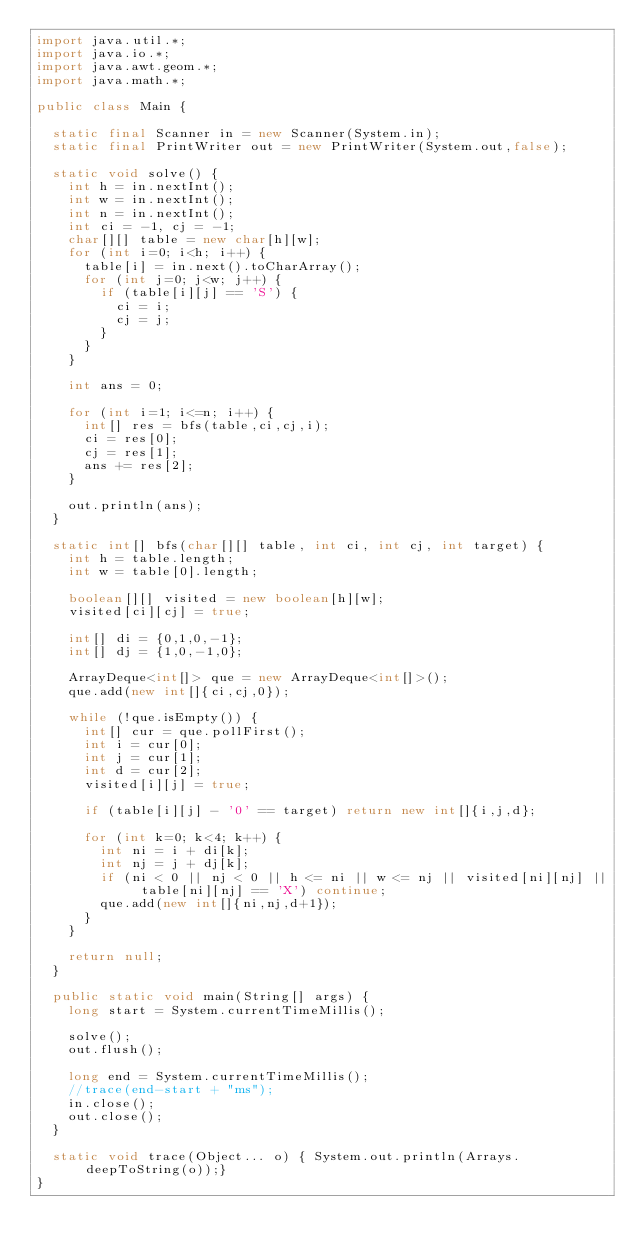Convert code to text. <code><loc_0><loc_0><loc_500><loc_500><_Java_>import java.util.*;
import java.io.*;
import java.awt.geom.*;
import java.math.*;

public class Main {

	static final Scanner in = new Scanner(System.in);
	static final PrintWriter out = new PrintWriter(System.out,false);

	static void solve() {
		int h = in.nextInt();
		int w = in.nextInt();
		int n = in.nextInt();
		int ci = -1, cj = -1;
		char[][] table = new char[h][w];
		for (int i=0; i<h; i++) {
			table[i] = in.next().toCharArray();
			for (int j=0; j<w; j++) {
				if (table[i][j] == 'S') {
					ci = i;
					cj = j;
				}
			}
		}

		int ans = 0;

		for (int i=1; i<=n; i++) {
			int[] res = bfs(table,ci,cj,i);
			ci = res[0];
			cj = res[1];
			ans += res[2];
		}

		out.println(ans);
	}

	static int[] bfs(char[][] table, int ci, int cj, int target) {
		int h = table.length;
		int w = table[0].length;

		boolean[][] visited = new boolean[h][w];
		visited[ci][cj] = true;

		int[] di = {0,1,0,-1};
		int[] dj = {1,0,-1,0};

		ArrayDeque<int[]> que = new ArrayDeque<int[]>();
		que.add(new int[]{ci,cj,0});

		while (!que.isEmpty()) {
			int[] cur = que.pollFirst();
			int i = cur[0];
			int j = cur[1];
			int d = cur[2];
			visited[i][j] = true;

			if (table[i][j] - '0' == target) return new int[]{i,j,d};

			for (int k=0; k<4; k++) {
				int ni = i + di[k];
				int nj = j + dj[k];
				if (ni < 0 || nj < 0 || h <= ni || w <= nj || visited[ni][nj] || table[ni][nj] == 'X') continue;
				que.add(new int[]{ni,nj,d+1});
			}
		}

		return null;
	}

	public static void main(String[] args) {
		long start = System.currentTimeMillis();

		solve();
		out.flush();

		long end = System.currentTimeMillis();
		//trace(end-start + "ms");
		in.close();
		out.close();
	}

	static void trace(Object... o) { System.out.println(Arrays.deepToString(o));}
}</code> 